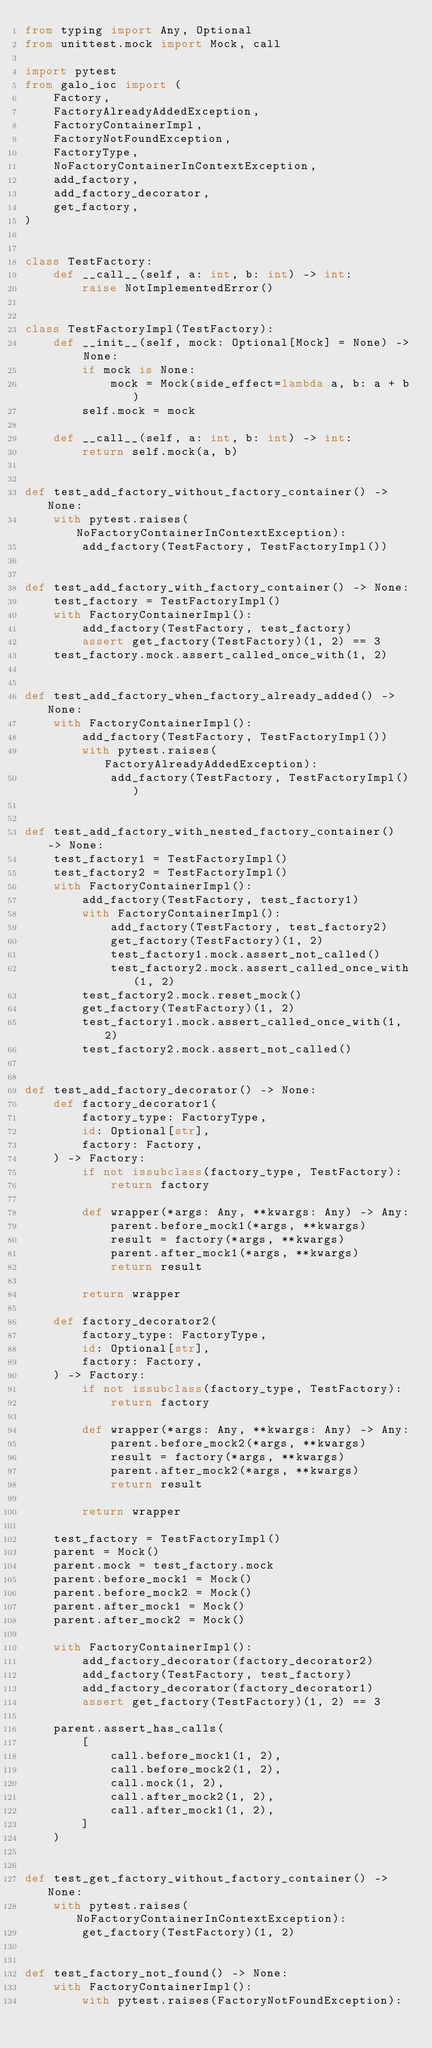Convert code to text. <code><loc_0><loc_0><loc_500><loc_500><_Python_>from typing import Any, Optional
from unittest.mock import Mock, call

import pytest
from galo_ioc import (
    Factory,
    FactoryAlreadyAddedException,
    FactoryContainerImpl,
    FactoryNotFoundException,
    FactoryType,
    NoFactoryContainerInContextException,
    add_factory,
    add_factory_decorator,
    get_factory,
)


class TestFactory:
    def __call__(self, a: int, b: int) -> int:
        raise NotImplementedError()


class TestFactoryImpl(TestFactory):
    def __init__(self, mock: Optional[Mock] = None) -> None:
        if mock is None:
            mock = Mock(side_effect=lambda a, b: a + b)
        self.mock = mock

    def __call__(self, a: int, b: int) -> int:
        return self.mock(a, b)


def test_add_factory_without_factory_container() -> None:
    with pytest.raises(NoFactoryContainerInContextException):
        add_factory(TestFactory, TestFactoryImpl())


def test_add_factory_with_factory_container() -> None:
    test_factory = TestFactoryImpl()
    with FactoryContainerImpl():
        add_factory(TestFactory, test_factory)
        assert get_factory(TestFactory)(1, 2) == 3
    test_factory.mock.assert_called_once_with(1, 2)


def test_add_factory_when_factory_already_added() -> None:
    with FactoryContainerImpl():
        add_factory(TestFactory, TestFactoryImpl())
        with pytest.raises(FactoryAlreadyAddedException):
            add_factory(TestFactory, TestFactoryImpl())


def test_add_factory_with_nested_factory_container() -> None:
    test_factory1 = TestFactoryImpl()
    test_factory2 = TestFactoryImpl()
    with FactoryContainerImpl():
        add_factory(TestFactory, test_factory1)
        with FactoryContainerImpl():
            add_factory(TestFactory, test_factory2)
            get_factory(TestFactory)(1, 2)
            test_factory1.mock.assert_not_called()
            test_factory2.mock.assert_called_once_with(1, 2)
        test_factory2.mock.reset_mock()
        get_factory(TestFactory)(1, 2)
        test_factory1.mock.assert_called_once_with(1, 2)
        test_factory2.mock.assert_not_called()


def test_add_factory_decorator() -> None:
    def factory_decorator1(
        factory_type: FactoryType,
        id: Optional[str],
        factory: Factory,
    ) -> Factory:
        if not issubclass(factory_type, TestFactory):
            return factory

        def wrapper(*args: Any, **kwargs: Any) -> Any:
            parent.before_mock1(*args, **kwargs)
            result = factory(*args, **kwargs)
            parent.after_mock1(*args, **kwargs)
            return result

        return wrapper

    def factory_decorator2(
        factory_type: FactoryType,
        id: Optional[str],
        factory: Factory,
    ) -> Factory:
        if not issubclass(factory_type, TestFactory):
            return factory

        def wrapper(*args: Any, **kwargs: Any) -> Any:
            parent.before_mock2(*args, **kwargs)
            result = factory(*args, **kwargs)
            parent.after_mock2(*args, **kwargs)
            return result

        return wrapper

    test_factory = TestFactoryImpl()
    parent = Mock()
    parent.mock = test_factory.mock
    parent.before_mock1 = Mock()
    parent.before_mock2 = Mock()
    parent.after_mock1 = Mock()
    parent.after_mock2 = Mock()

    with FactoryContainerImpl():
        add_factory_decorator(factory_decorator2)
        add_factory(TestFactory, test_factory)
        add_factory_decorator(factory_decorator1)
        assert get_factory(TestFactory)(1, 2) == 3

    parent.assert_has_calls(
        [
            call.before_mock1(1, 2),
            call.before_mock2(1, 2),
            call.mock(1, 2),
            call.after_mock2(1, 2),
            call.after_mock1(1, 2),
        ]
    )


def test_get_factory_without_factory_container() -> None:
    with pytest.raises(NoFactoryContainerInContextException):
        get_factory(TestFactory)(1, 2)


def test_factory_not_found() -> None:
    with FactoryContainerImpl():
        with pytest.raises(FactoryNotFoundException):</code> 